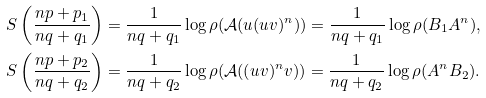Convert formula to latex. <formula><loc_0><loc_0><loc_500><loc_500>S \left ( \frac { n p + p _ { 1 } } { n q + q _ { 1 } } \right ) & = \frac { 1 } { n q + q _ { 1 } } \log \rho ( \mathcal { A } ( u ( u v ) ^ { n } ) ) = \frac { 1 } { n q + q _ { 1 } } \log \rho ( B _ { 1 } A ^ { n } ) , \\ S \left ( \frac { n p + p _ { 2 } } { n q + q _ { 2 } } \right ) & = \frac { 1 } { n q + q _ { 2 } } \log \rho ( \mathcal { A } ( ( u v ) ^ { n } v ) ) = \frac { 1 } { n q + q _ { 2 } } \log \rho ( A ^ { n } B _ { 2 } ) .</formula> 